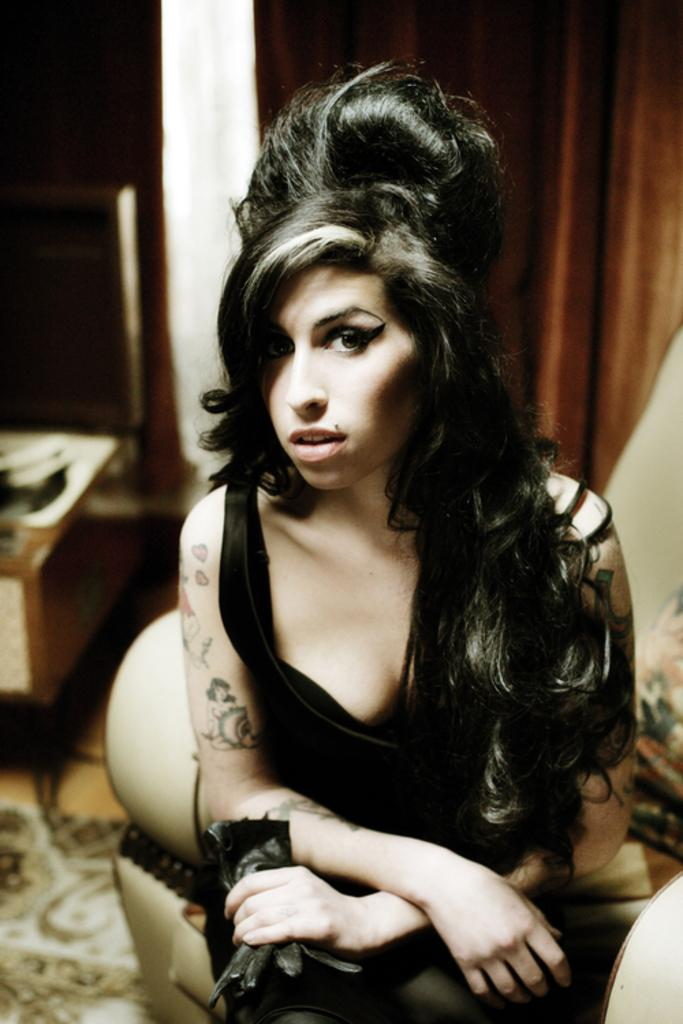What is the woman in the image doing? The woman is sitting in the image. What is the woman wearing? The woman is wearing a black dress. What type of furniture is in the image? There is a couch in the image. What type of window treatment is present in the image? There is a curtain in the image. What type of floor covering is visible in the image? There is a carpet on the floor in the image. What type of bread can be seen on the altar in the image? There is no altar or bread present in the image; it features a woman sitting on a couch in a room with a curtain and carpet. 